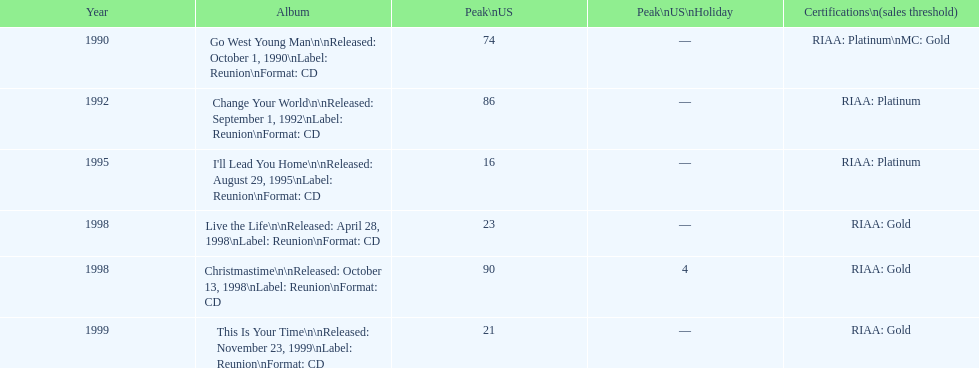Which michael w smith album had the highest ranking on the us chart? I'll Lead You Home. 